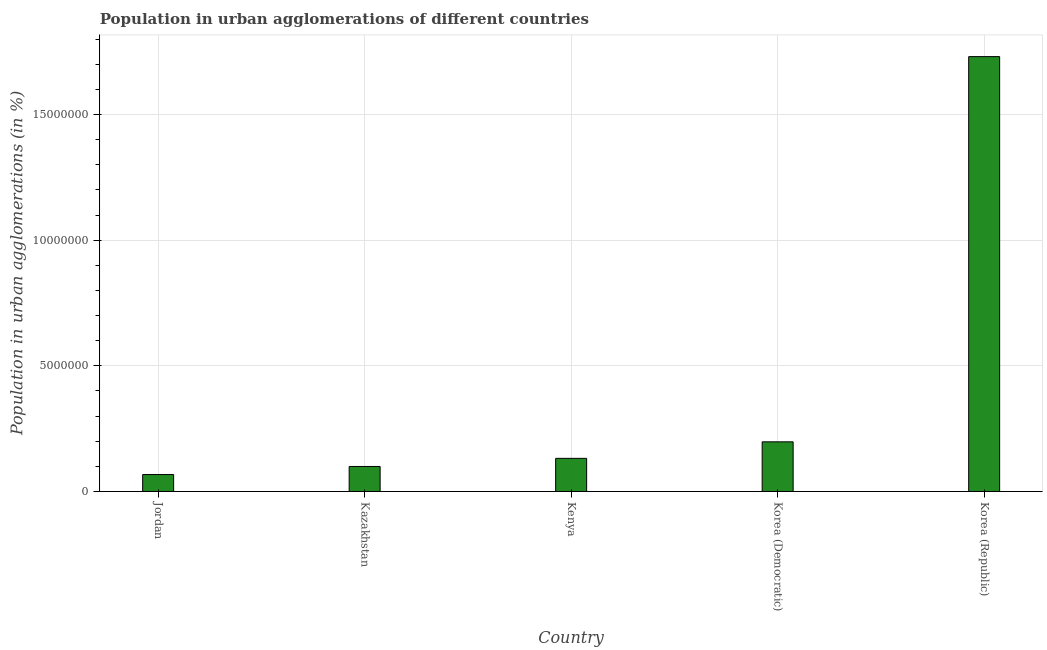Does the graph contain grids?
Give a very brief answer. Yes. What is the title of the graph?
Give a very brief answer. Population in urban agglomerations of different countries. What is the label or title of the X-axis?
Make the answer very short. Country. What is the label or title of the Y-axis?
Provide a short and direct response. Population in urban agglomerations (in %). What is the population in urban agglomerations in Kenya?
Your response must be concise. 1.32e+06. Across all countries, what is the maximum population in urban agglomerations?
Provide a succinct answer. 1.73e+07. Across all countries, what is the minimum population in urban agglomerations?
Make the answer very short. 6.74e+05. In which country was the population in urban agglomerations minimum?
Provide a succinct answer. Jordan. What is the sum of the population in urban agglomerations?
Offer a terse response. 2.23e+07. What is the difference between the population in urban agglomerations in Kazakhstan and Korea (Republic)?
Your answer should be compact. -1.63e+07. What is the average population in urban agglomerations per country?
Your answer should be very brief. 4.45e+06. What is the median population in urban agglomerations?
Your response must be concise. 1.32e+06. What is the ratio of the population in urban agglomerations in Korea (Democratic) to that in Korea (Republic)?
Your answer should be very brief. 0.11. Is the population in urban agglomerations in Kenya less than that in Korea (Democratic)?
Make the answer very short. Yes. Is the difference between the population in urban agglomerations in Jordan and Kazakhstan greater than the difference between any two countries?
Provide a short and direct response. No. What is the difference between the highest and the second highest population in urban agglomerations?
Your answer should be very brief. 1.53e+07. What is the difference between the highest and the lowest population in urban agglomerations?
Your answer should be compact. 1.66e+07. Are all the bars in the graph horizontal?
Your answer should be compact. No. What is the Population in urban agglomerations (in %) of Jordan?
Make the answer very short. 6.74e+05. What is the Population in urban agglomerations (in %) of Kazakhstan?
Offer a very short reply. 9.95e+05. What is the Population in urban agglomerations (in %) of Kenya?
Offer a very short reply. 1.32e+06. What is the Population in urban agglomerations (in %) in Korea (Democratic)?
Give a very brief answer. 1.98e+06. What is the Population in urban agglomerations (in %) in Korea (Republic)?
Provide a short and direct response. 1.73e+07. What is the difference between the Population in urban agglomerations (in %) in Jordan and Kazakhstan?
Your answer should be very brief. -3.21e+05. What is the difference between the Population in urban agglomerations (in %) in Jordan and Kenya?
Provide a short and direct response. -6.45e+05. What is the difference between the Population in urban agglomerations (in %) in Jordan and Korea (Democratic)?
Give a very brief answer. -1.30e+06. What is the difference between the Population in urban agglomerations (in %) in Jordan and Korea (Republic)?
Ensure brevity in your answer.  -1.66e+07. What is the difference between the Population in urban agglomerations (in %) in Kazakhstan and Kenya?
Give a very brief answer. -3.23e+05. What is the difference between the Population in urban agglomerations (in %) in Kazakhstan and Korea (Democratic)?
Keep it short and to the point. -9.81e+05. What is the difference between the Population in urban agglomerations (in %) in Kazakhstan and Korea (Republic)?
Give a very brief answer. -1.63e+07. What is the difference between the Population in urban agglomerations (in %) in Kenya and Korea (Democratic)?
Give a very brief answer. -6.57e+05. What is the difference between the Population in urban agglomerations (in %) in Kenya and Korea (Republic)?
Keep it short and to the point. -1.60e+07. What is the difference between the Population in urban agglomerations (in %) in Korea (Democratic) and Korea (Republic)?
Give a very brief answer. -1.53e+07. What is the ratio of the Population in urban agglomerations (in %) in Jordan to that in Kazakhstan?
Offer a very short reply. 0.68. What is the ratio of the Population in urban agglomerations (in %) in Jordan to that in Kenya?
Offer a very short reply. 0.51. What is the ratio of the Population in urban agglomerations (in %) in Jordan to that in Korea (Democratic)?
Give a very brief answer. 0.34. What is the ratio of the Population in urban agglomerations (in %) in Jordan to that in Korea (Republic)?
Ensure brevity in your answer.  0.04. What is the ratio of the Population in urban agglomerations (in %) in Kazakhstan to that in Kenya?
Ensure brevity in your answer.  0.76. What is the ratio of the Population in urban agglomerations (in %) in Kazakhstan to that in Korea (Democratic)?
Provide a short and direct response. 0.5. What is the ratio of the Population in urban agglomerations (in %) in Kazakhstan to that in Korea (Republic)?
Give a very brief answer. 0.06. What is the ratio of the Population in urban agglomerations (in %) in Kenya to that in Korea (Democratic)?
Your response must be concise. 0.67. What is the ratio of the Population in urban agglomerations (in %) in Kenya to that in Korea (Republic)?
Your response must be concise. 0.08. What is the ratio of the Population in urban agglomerations (in %) in Korea (Democratic) to that in Korea (Republic)?
Your answer should be compact. 0.11. 